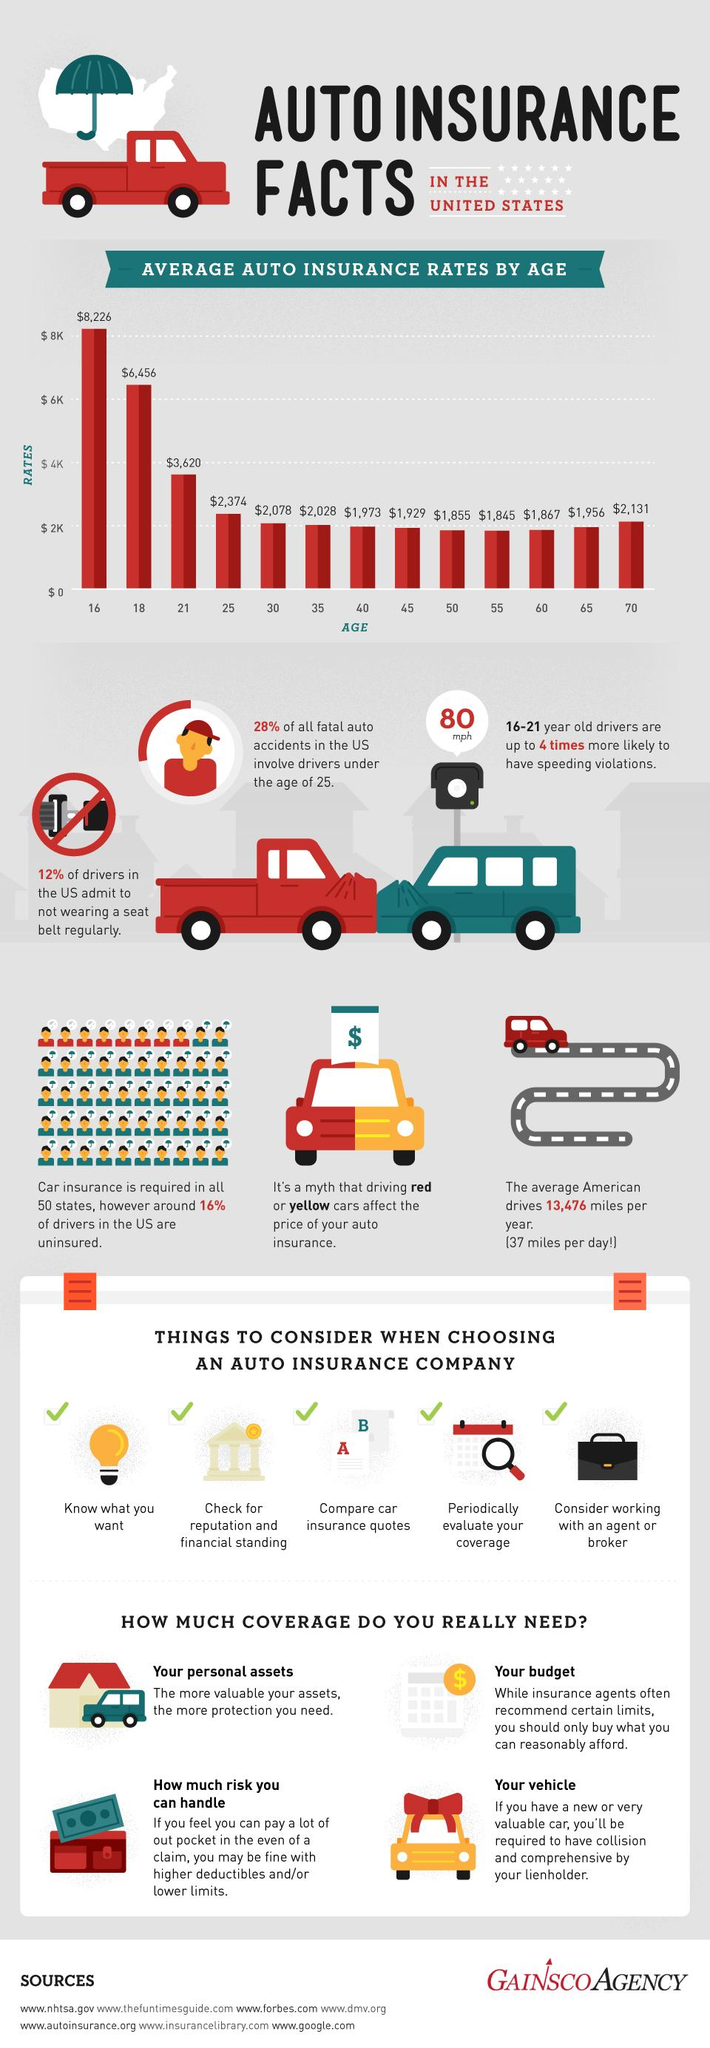Mention a couple of crucial points in this snapshot. According to recent statistics, approximately 16% of U.S. drivers are not insured. The second lowest auto insurance rates are allowed for individuals aged 50 and above. The auto insurance rates for two age groups are above $6,000. The auto insurance rate of $6,456 is allowed for individuals aged 18 and above. Drivers under the age of 25 are more likely to be involved in auto accidents compared to drivers in other age groups. 